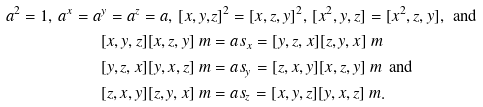<formula> <loc_0><loc_0><loc_500><loc_500>a ^ { 2 } = 1 , \, a ^ { x } = a ^ { y } = a ^ { z } = a , \, [ x , y , & z ] ^ { 2 } = [ x , z , y ] ^ { 2 } , \, [ x ^ { 2 } , y , z ] = [ x ^ { 2 } , z , y ] , \text {\, and} \\ [ x , y , z ] [ x , z , y ] \ m & = a s _ { x } = [ y , z , x ] [ z , y , x ] \ m \, \\ [ y , z , x ] [ y , x , z ] \ m & = a s _ { y } = [ z , x , y ] [ x , z , y ] \ m \text {\, and \,} \\ [ z , x , y ] [ z , y , x ] \ m & = a s _ { z } = [ x , y , z ] [ y , x , z ] \ m .</formula> 